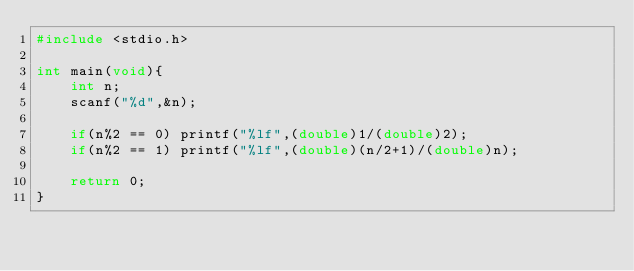<code> <loc_0><loc_0><loc_500><loc_500><_C_>#include <stdio.h>
 
int main(void){
    int n;
    scanf("%d",&n);
    
    if(n%2 == 0) printf("%lf",(double)1/(double)2);
    if(n%2 == 1) printf("%lf",(double)(n/2+1)/(double)n);
  
    return 0;
}</code> 